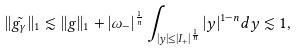Convert formula to latex. <formula><loc_0><loc_0><loc_500><loc_500>| | \tilde { g _ { \gamma } } | | _ { 1 } \lesssim | | g | | _ { 1 } + | \omega _ { - } | ^ { \frac { 1 } { n } } \int _ { | { y } | \leq | I _ { + } | ^ { \frac { 1 } { n } } } | { y } | ^ { 1 - n } d { y } \lesssim 1 ,</formula> 